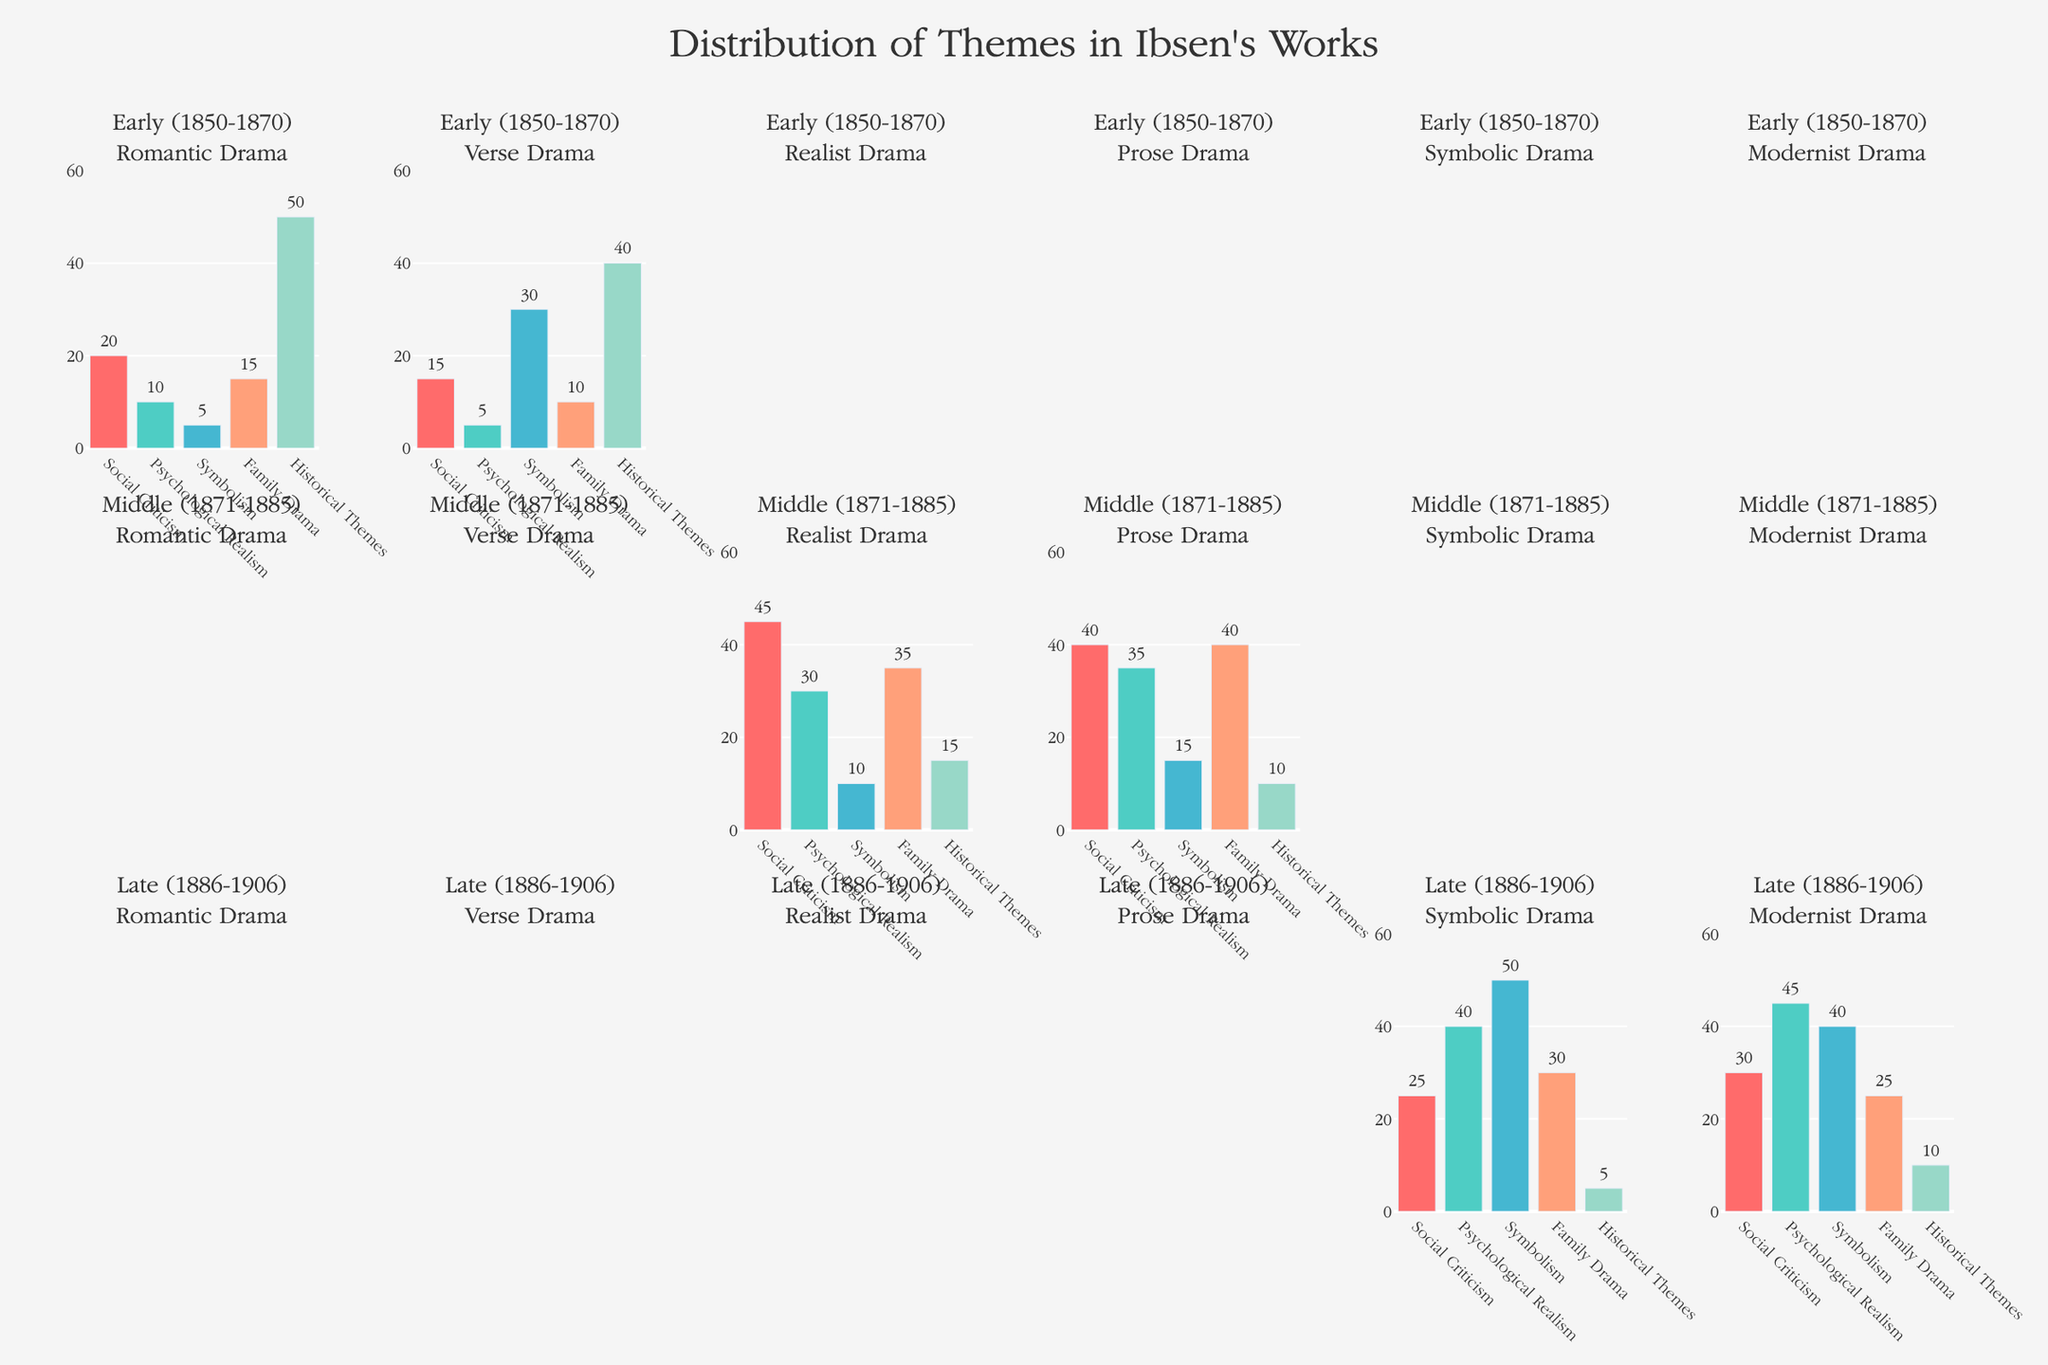Which genre in the Early (1850-1870) period has the highest representation of Historical Themes? Look at the subplots in the first row representing the Early (1850-1870) period and compare the heights of the bars for Historical Themes for each genre. The Romantic Drama genre has a Historical Themes bar much higher (50) than other genres.
Answer: Romantic Drama What is the total representation of Social Criticism themes in the Middle (1871-1885) period? Examine the subplots in the second row representing the Middle (1871-1885) period. Sum the heights of the Social Criticism bars for Realist Drama (45) and Prose Drama (40), which results in 85.
Answer: 85 Which period and genre combination has the highest representation of Psychological Realism? Browse through each subplot and compare the heights of the Psychological Realism bars. The subplot for the Late (1886-1906) period and Modernist Drama genre has the highest representation at 45.
Answer: Late (1886-1906) - Modernist Drama Is Symbolism more prominent in the Late (1886-1906) period or the Middle (1871-1885) period? Compare the Symbolism bars in the subplots of the Middle and Late periods. The Symbolism bars in the Late period for Symbolic Drama (50) and Modernist Drama (40) sum to 90, whereas for the Middle period, Realist Drama (10) and Prose Drama (15) sum to 25. Thus, Symbolism is more prominent in the Late period.
Answer: Late (1886-1906) Which genre in the Middle (1871-1885) period focuses more on Family Drama? Focus on the subplots in the second row representing the Middle period and compare the heights of the Family Drama bars. Prose Drama has a Family Drama representation of 40, which is higher than Realist Drama's 35.
Answer: Prose Drama What is the most frequent theme across all periods and genres? For each theme, sum up its representation across all period-genre combinations. The Family Drama theme has the highest overall sum: 15 + 10 + 35 + 40 + 30 + 25 = 155.
Answer: Family Drama How does the representation of Social Criticism in Early (1850-1870) Romantic Drama compare to Late (1886-1906) Modernist Drama? Compare the heights of the Social Criticism bars for Early Romantic Drama (20) and Late Modernist Drama (30). The Late Modernist Drama has a higher representation of Social Criticism than Early Romantic Drama.
Answer: Higher in Late Modernist Drama 